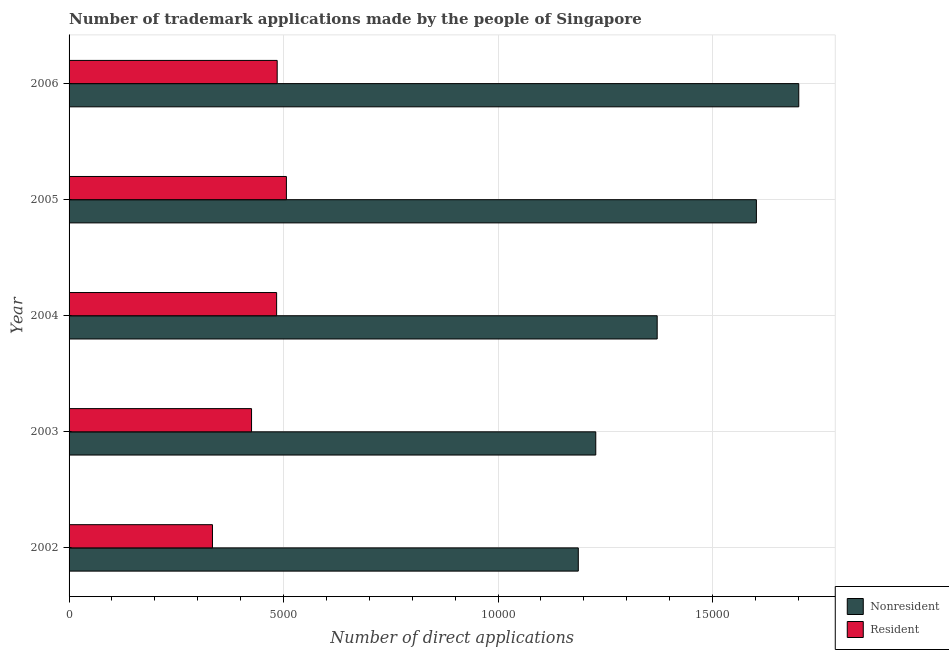How many groups of bars are there?
Your response must be concise. 5. In how many cases, is the number of bars for a given year not equal to the number of legend labels?
Make the answer very short. 0. What is the number of trademark applications made by non residents in 2006?
Ensure brevity in your answer.  1.70e+04. Across all years, what is the maximum number of trademark applications made by residents?
Provide a succinct answer. 5067. Across all years, what is the minimum number of trademark applications made by non residents?
Keep it short and to the point. 1.19e+04. In which year was the number of trademark applications made by non residents minimum?
Your answer should be compact. 2002. What is the total number of trademark applications made by residents in the graph?
Make the answer very short. 2.24e+04. What is the difference between the number of trademark applications made by non residents in 2005 and that in 2006?
Offer a terse response. -988. What is the difference between the number of trademark applications made by non residents in 2004 and the number of trademark applications made by residents in 2005?
Make the answer very short. 8644. What is the average number of trademark applications made by non residents per year?
Give a very brief answer. 1.42e+04. In the year 2002, what is the difference between the number of trademark applications made by residents and number of trademark applications made by non residents?
Keep it short and to the point. -8529. What is the ratio of the number of trademark applications made by residents in 2002 to that in 2006?
Your response must be concise. 0.69. Is the number of trademark applications made by residents in 2002 less than that in 2006?
Provide a short and direct response. Yes. What is the difference between the highest and the second highest number of trademark applications made by residents?
Make the answer very short. 215. What is the difference between the highest and the lowest number of trademark applications made by residents?
Keep it short and to the point. 1724. In how many years, is the number of trademark applications made by non residents greater than the average number of trademark applications made by non residents taken over all years?
Your response must be concise. 2. What does the 1st bar from the top in 2004 represents?
Make the answer very short. Resident. What does the 1st bar from the bottom in 2005 represents?
Offer a very short reply. Nonresident. How many years are there in the graph?
Your response must be concise. 5. Are the values on the major ticks of X-axis written in scientific E-notation?
Make the answer very short. No. Does the graph contain any zero values?
Make the answer very short. No. Does the graph contain grids?
Provide a short and direct response. Yes. How many legend labels are there?
Offer a terse response. 2. How are the legend labels stacked?
Your response must be concise. Vertical. What is the title of the graph?
Your answer should be very brief. Number of trademark applications made by the people of Singapore. What is the label or title of the X-axis?
Provide a short and direct response. Number of direct applications. What is the Number of direct applications of Nonresident in 2002?
Offer a terse response. 1.19e+04. What is the Number of direct applications of Resident in 2002?
Ensure brevity in your answer.  3343. What is the Number of direct applications of Nonresident in 2003?
Keep it short and to the point. 1.23e+04. What is the Number of direct applications in Resident in 2003?
Make the answer very short. 4254. What is the Number of direct applications in Nonresident in 2004?
Your answer should be very brief. 1.37e+04. What is the Number of direct applications of Resident in 2004?
Your answer should be very brief. 4839. What is the Number of direct applications of Nonresident in 2005?
Keep it short and to the point. 1.60e+04. What is the Number of direct applications in Resident in 2005?
Keep it short and to the point. 5067. What is the Number of direct applications of Nonresident in 2006?
Ensure brevity in your answer.  1.70e+04. What is the Number of direct applications in Resident in 2006?
Your answer should be very brief. 4852. Across all years, what is the maximum Number of direct applications of Nonresident?
Give a very brief answer. 1.70e+04. Across all years, what is the maximum Number of direct applications of Resident?
Offer a very short reply. 5067. Across all years, what is the minimum Number of direct applications of Nonresident?
Provide a short and direct response. 1.19e+04. Across all years, what is the minimum Number of direct applications of Resident?
Provide a short and direct response. 3343. What is the total Number of direct applications of Nonresident in the graph?
Offer a terse response. 7.09e+04. What is the total Number of direct applications of Resident in the graph?
Offer a terse response. 2.24e+04. What is the difference between the Number of direct applications of Nonresident in 2002 and that in 2003?
Ensure brevity in your answer.  -407. What is the difference between the Number of direct applications of Resident in 2002 and that in 2003?
Make the answer very short. -911. What is the difference between the Number of direct applications of Nonresident in 2002 and that in 2004?
Provide a succinct answer. -1839. What is the difference between the Number of direct applications in Resident in 2002 and that in 2004?
Offer a very short reply. -1496. What is the difference between the Number of direct applications of Nonresident in 2002 and that in 2005?
Provide a short and direct response. -4152. What is the difference between the Number of direct applications in Resident in 2002 and that in 2005?
Make the answer very short. -1724. What is the difference between the Number of direct applications of Nonresident in 2002 and that in 2006?
Keep it short and to the point. -5140. What is the difference between the Number of direct applications in Resident in 2002 and that in 2006?
Provide a succinct answer. -1509. What is the difference between the Number of direct applications of Nonresident in 2003 and that in 2004?
Your answer should be compact. -1432. What is the difference between the Number of direct applications in Resident in 2003 and that in 2004?
Ensure brevity in your answer.  -585. What is the difference between the Number of direct applications of Nonresident in 2003 and that in 2005?
Give a very brief answer. -3745. What is the difference between the Number of direct applications of Resident in 2003 and that in 2005?
Provide a succinct answer. -813. What is the difference between the Number of direct applications in Nonresident in 2003 and that in 2006?
Your answer should be very brief. -4733. What is the difference between the Number of direct applications in Resident in 2003 and that in 2006?
Your answer should be compact. -598. What is the difference between the Number of direct applications in Nonresident in 2004 and that in 2005?
Ensure brevity in your answer.  -2313. What is the difference between the Number of direct applications of Resident in 2004 and that in 2005?
Provide a succinct answer. -228. What is the difference between the Number of direct applications in Nonresident in 2004 and that in 2006?
Ensure brevity in your answer.  -3301. What is the difference between the Number of direct applications of Nonresident in 2005 and that in 2006?
Your answer should be compact. -988. What is the difference between the Number of direct applications of Resident in 2005 and that in 2006?
Provide a succinct answer. 215. What is the difference between the Number of direct applications of Nonresident in 2002 and the Number of direct applications of Resident in 2003?
Offer a very short reply. 7618. What is the difference between the Number of direct applications of Nonresident in 2002 and the Number of direct applications of Resident in 2004?
Offer a terse response. 7033. What is the difference between the Number of direct applications of Nonresident in 2002 and the Number of direct applications of Resident in 2005?
Your answer should be compact. 6805. What is the difference between the Number of direct applications of Nonresident in 2002 and the Number of direct applications of Resident in 2006?
Your response must be concise. 7020. What is the difference between the Number of direct applications in Nonresident in 2003 and the Number of direct applications in Resident in 2004?
Keep it short and to the point. 7440. What is the difference between the Number of direct applications in Nonresident in 2003 and the Number of direct applications in Resident in 2005?
Offer a very short reply. 7212. What is the difference between the Number of direct applications in Nonresident in 2003 and the Number of direct applications in Resident in 2006?
Give a very brief answer. 7427. What is the difference between the Number of direct applications of Nonresident in 2004 and the Number of direct applications of Resident in 2005?
Give a very brief answer. 8644. What is the difference between the Number of direct applications of Nonresident in 2004 and the Number of direct applications of Resident in 2006?
Ensure brevity in your answer.  8859. What is the difference between the Number of direct applications in Nonresident in 2005 and the Number of direct applications in Resident in 2006?
Your answer should be very brief. 1.12e+04. What is the average Number of direct applications in Nonresident per year?
Offer a very short reply. 1.42e+04. What is the average Number of direct applications in Resident per year?
Provide a succinct answer. 4471. In the year 2002, what is the difference between the Number of direct applications of Nonresident and Number of direct applications of Resident?
Provide a short and direct response. 8529. In the year 2003, what is the difference between the Number of direct applications in Nonresident and Number of direct applications in Resident?
Make the answer very short. 8025. In the year 2004, what is the difference between the Number of direct applications of Nonresident and Number of direct applications of Resident?
Keep it short and to the point. 8872. In the year 2005, what is the difference between the Number of direct applications of Nonresident and Number of direct applications of Resident?
Give a very brief answer. 1.10e+04. In the year 2006, what is the difference between the Number of direct applications of Nonresident and Number of direct applications of Resident?
Offer a very short reply. 1.22e+04. What is the ratio of the Number of direct applications of Nonresident in 2002 to that in 2003?
Provide a succinct answer. 0.97. What is the ratio of the Number of direct applications in Resident in 2002 to that in 2003?
Your answer should be very brief. 0.79. What is the ratio of the Number of direct applications in Nonresident in 2002 to that in 2004?
Keep it short and to the point. 0.87. What is the ratio of the Number of direct applications of Resident in 2002 to that in 2004?
Offer a very short reply. 0.69. What is the ratio of the Number of direct applications in Nonresident in 2002 to that in 2005?
Keep it short and to the point. 0.74. What is the ratio of the Number of direct applications in Resident in 2002 to that in 2005?
Offer a very short reply. 0.66. What is the ratio of the Number of direct applications of Nonresident in 2002 to that in 2006?
Offer a very short reply. 0.7. What is the ratio of the Number of direct applications in Resident in 2002 to that in 2006?
Your answer should be compact. 0.69. What is the ratio of the Number of direct applications of Nonresident in 2003 to that in 2004?
Provide a short and direct response. 0.9. What is the ratio of the Number of direct applications of Resident in 2003 to that in 2004?
Offer a very short reply. 0.88. What is the ratio of the Number of direct applications of Nonresident in 2003 to that in 2005?
Offer a terse response. 0.77. What is the ratio of the Number of direct applications of Resident in 2003 to that in 2005?
Provide a succinct answer. 0.84. What is the ratio of the Number of direct applications in Nonresident in 2003 to that in 2006?
Ensure brevity in your answer.  0.72. What is the ratio of the Number of direct applications of Resident in 2003 to that in 2006?
Make the answer very short. 0.88. What is the ratio of the Number of direct applications of Nonresident in 2004 to that in 2005?
Your answer should be very brief. 0.86. What is the ratio of the Number of direct applications in Resident in 2004 to that in 2005?
Offer a very short reply. 0.95. What is the ratio of the Number of direct applications in Nonresident in 2004 to that in 2006?
Make the answer very short. 0.81. What is the ratio of the Number of direct applications in Resident in 2004 to that in 2006?
Your response must be concise. 1. What is the ratio of the Number of direct applications of Nonresident in 2005 to that in 2006?
Provide a short and direct response. 0.94. What is the ratio of the Number of direct applications in Resident in 2005 to that in 2006?
Your response must be concise. 1.04. What is the difference between the highest and the second highest Number of direct applications of Nonresident?
Your response must be concise. 988. What is the difference between the highest and the second highest Number of direct applications in Resident?
Ensure brevity in your answer.  215. What is the difference between the highest and the lowest Number of direct applications in Nonresident?
Offer a terse response. 5140. What is the difference between the highest and the lowest Number of direct applications in Resident?
Provide a short and direct response. 1724. 